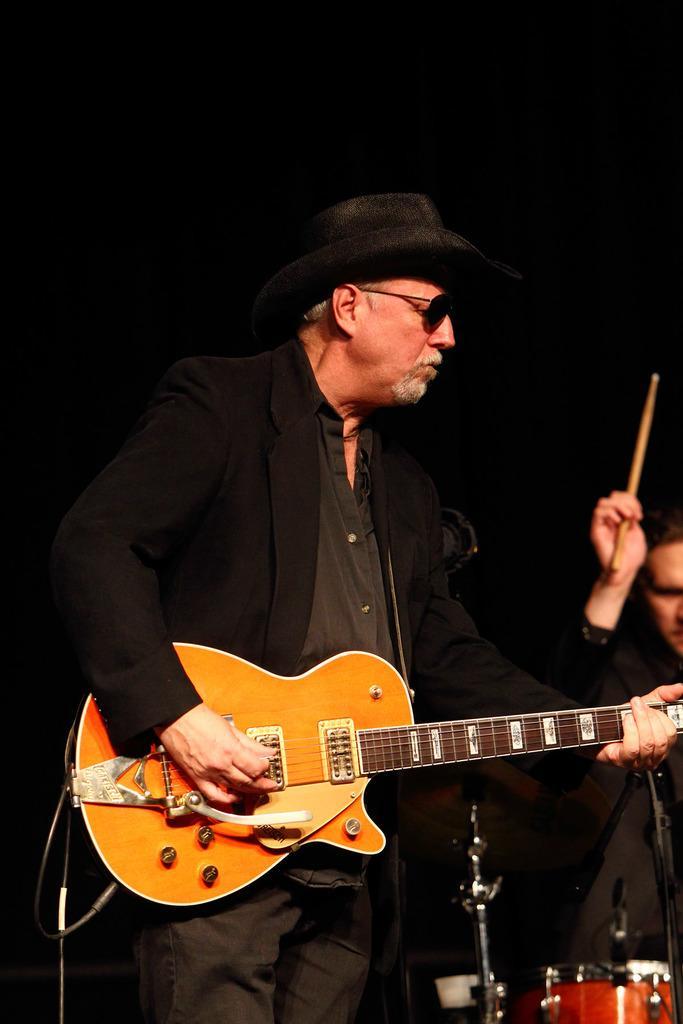Describe this image in one or two sentences. In this picture we can see 2 people who are wearing black colored blazers and the left most person is holding guitar, seems like playing it, he also wears hat and spectacles. And the right most person has stick in his hand, he looks like playing drum which is in front of him. 